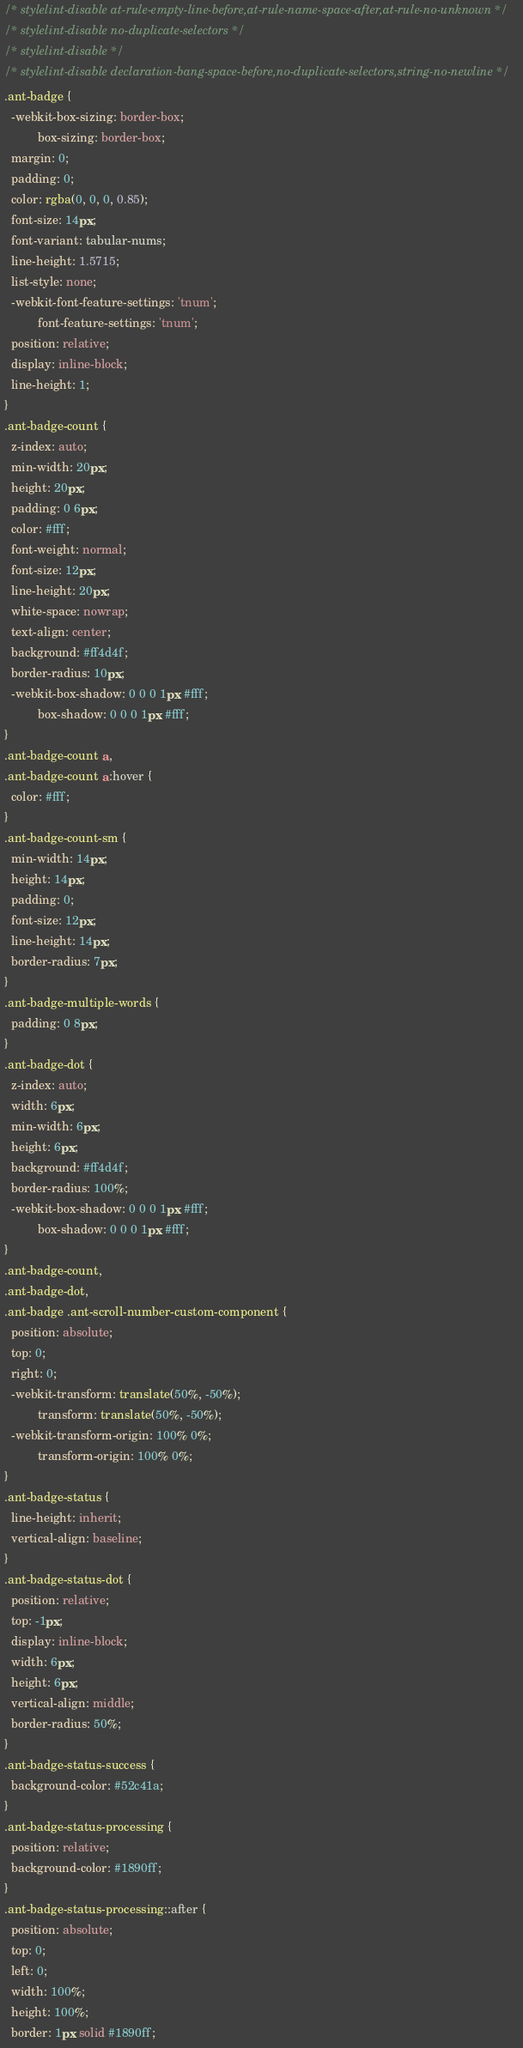Convert code to text. <code><loc_0><loc_0><loc_500><loc_500><_CSS_>/* stylelint-disable at-rule-empty-line-before,at-rule-name-space-after,at-rule-no-unknown */
/* stylelint-disable no-duplicate-selectors */
/* stylelint-disable */
/* stylelint-disable declaration-bang-space-before,no-duplicate-selectors,string-no-newline */
.ant-badge {
  -webkit-box-sizing: border-box;
          box-sizing: border-box;
  margin: 0;
  padding: 0;
  color: rgba(0, 0, 0, 0.85);
  font-size: 14px;
  font-variant: tabular-nums;
  line-height: 1.5715;
  list-style: none;
  -webkit-font-feature-settings: 'tnum';
          font-feature-settings: 'tnum';
  position: relative;
  display: inline-block;
  line-height: 1;
}
.ant-badge-count {
  z-index: auto;
  min-width: 20px;
  height: 20px;
  padding: 0 6px;
  color: #fff;
  font-weight: normal;
  font-size: 12px;
  line-height: 20px;
  white-space: nowrap;
  text-align: center;
  background: #ff4d4f;
  border-radius: 10px;
  -webkit-box-shadow: 0 0 0 1px #fff;
          box-shadow: 0 0 0 1px #fff;
}
.ant-badge-count a,
.ant-badge-count a:hover {
  color: #fff;
}
.ant-badge-count-sm {
  min-width: 14px;
  height: 14px;
  padding: 0;
  font-size: 12px;
  line-height: 14px;
  border-radius: 7px;
}
.ant-badge-multiple-words {
  padding: 0 8px;
}
.ant-badge-dot {
  z-index: auto;
  width: 6px;
  min-width: 6px;
  height: 6px;
  background: #ff4d4f;
  border-radius: 100%;
  -webkit-box-shadow: 0 0 0 1px #fff;
          box-shadow: 0 0 0 1px #fff;
}
.ant-badge-count,
.ant-badge-dot,
.ant-badge .ant-scroll-number-custom-component {
  position: absolute;
  top: 0;
  right: 0;
  -webkit-transform: translate(50%, -50%);
          transform: translate(50%, -50%);
  -webkit-transform-origin: 100% 0%;
          transform-origin: 100% 0%;
}
.ant-badge-status {
  line-height: inherit;
  vertical-align: baseline;
}
.ant-badge-status-dot {
  position: relative;
  top: -1px;
  display: inline-block;
  width: 6px;
  height: 6px;
  vertical-align: middle;
  border-radius: 50%;
}
.ant-badge-status-success {
  background-color: #52c41a;
}
.ant-badge-status-processing {
  position: relative;
  background-color: #1890ff;
}
.ant-badge-status-processing::after {
  position: absolute;
  top: 0;
  left: 0;
  width: 100%;
  height: 100%;
  border: 1px solid #1890ff;</code> 